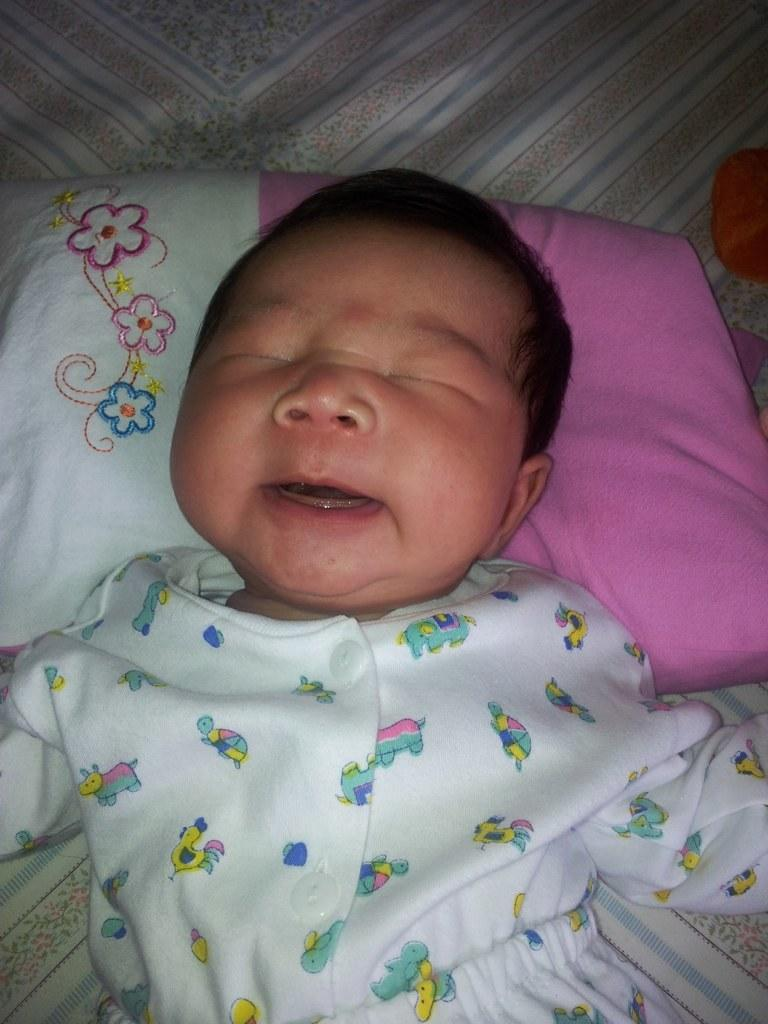What is the main subject of the image? There is a small baby in the image. Where is the baby located? The baby is lying on a bed. What is present on the bed with the baby? There is a pillow and a bed sheet in the image. What type of jeans is the baby wearing in the image? The baby is not wearing jeans in the image; they are lying on a bed with a pillow and a bed sheet. Can you see a stamp on the baby's forehead in the image? There is no stamp visible on the baby's forehead in the image. 